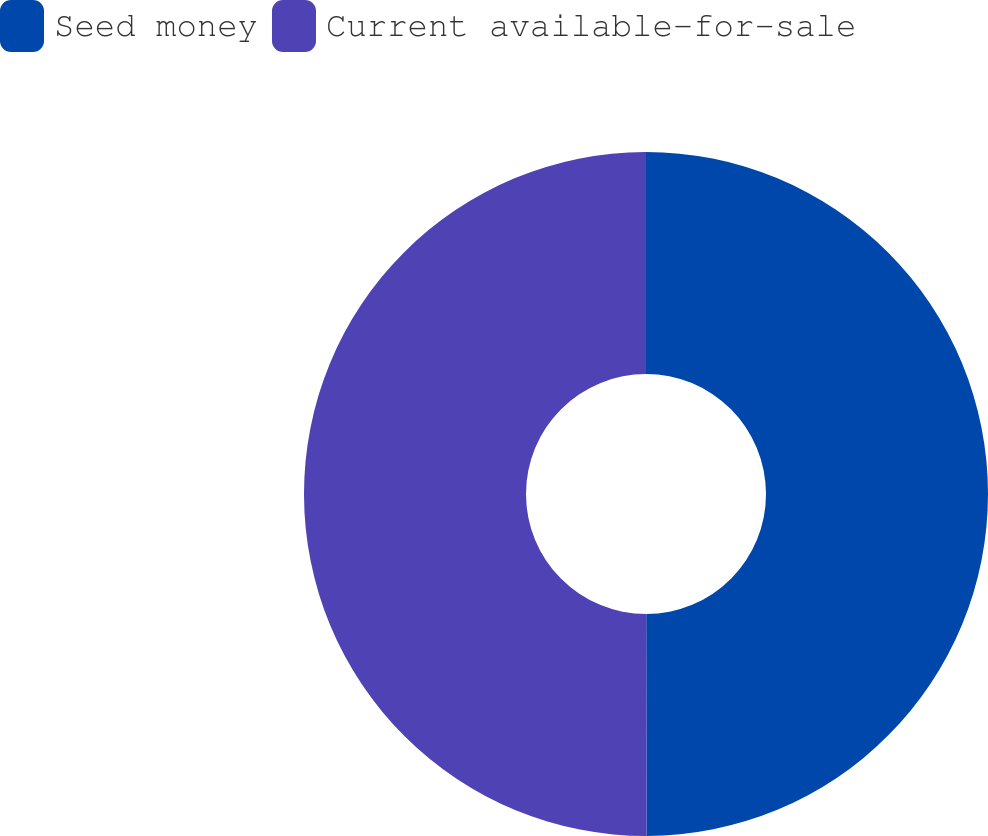<chart> <loc_0><loc_0><loc_500><loc_500><pie_chart><fcel>Seed money<fcel>Current available-for-sale<nl><fcel>49.97%<fcel>50.03%<nl></chart> 